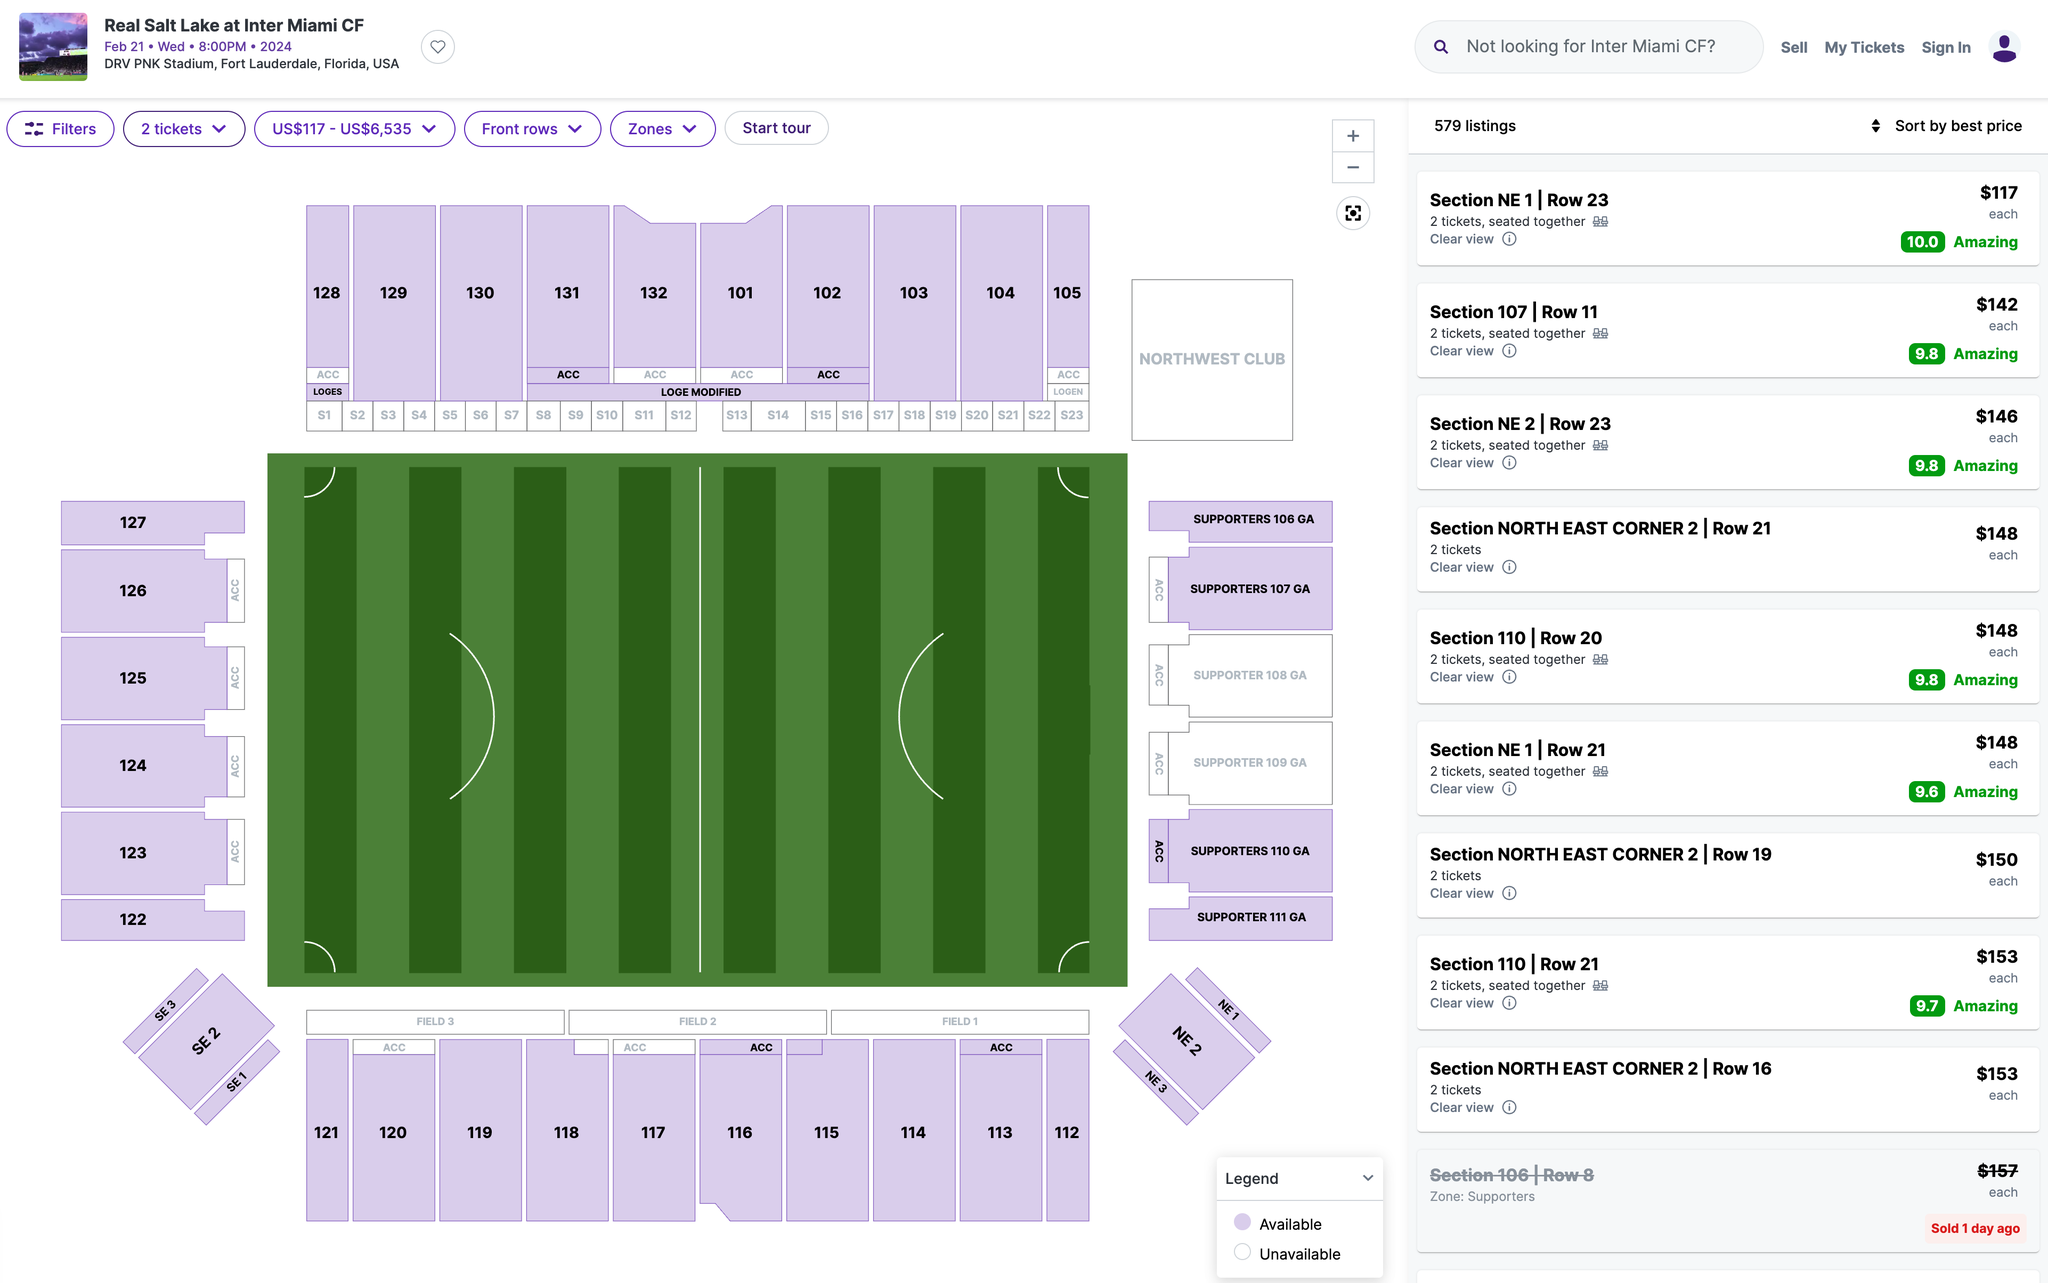Which section's ticket would you recommend I purchase? I recommend purchasing tickets in Section 107. This section is located on the west side of the stadium and offers a great view of the field. Additionally, this section is relatively close to the center of the stadium, making it easy to get to and from your seat. 